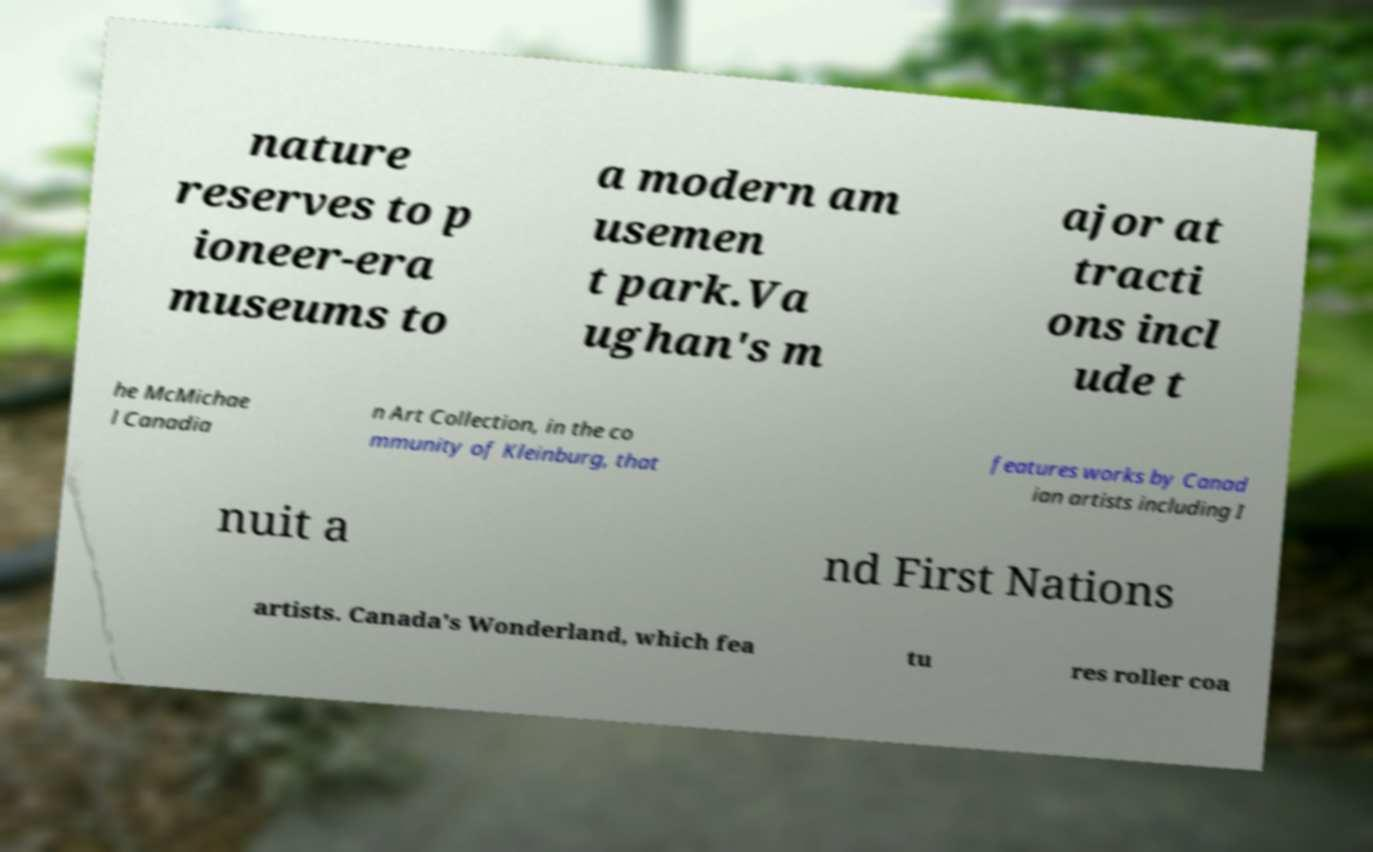Please identify and transcribe the text found in this image. nature reserves to p ioneer-era museums to a modern am usemen t park.Va ughan's m ajor at tracti ons incl ude t he McMichae l Canadia n Art Collection, in the co mmunity of Kleinburg, that features works by Canad ian artists including I nuit a nd First Nations artists. Canada's Wonderland, which fea tu res roller coa 